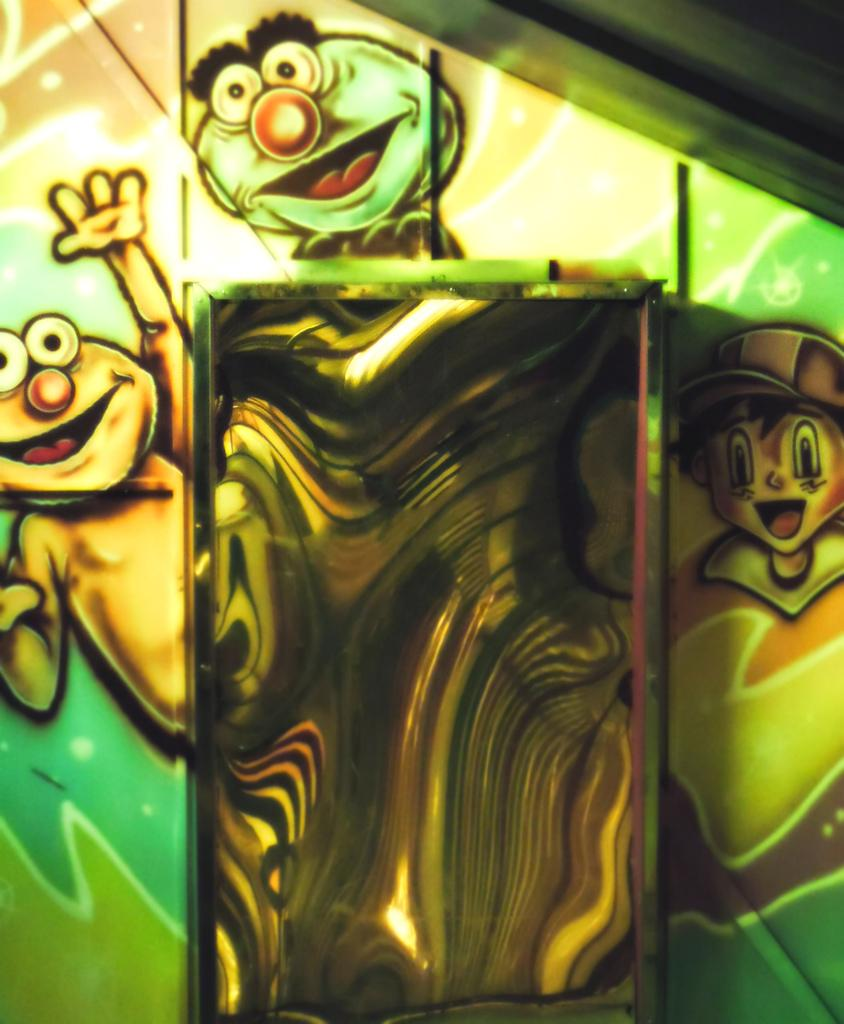What is depicted in the image? There is a painting of cartoon characters in the image. What can be inferred about the nature of the painting? The painting is likely colorful and playful, given that it features cartoon characters. On what surface is the painting placed? The painting is on a surface, but the specific type of surface is not mentioned in the facts. What type of crime is being committed by the cartoon characters in the image? There is no indication of any crime being committed in the image; it features a painting of cartoon characters. What hobbies do the cartoon characters in the image enjoy? The facts provided do not give any information about the hobbies of the cartoon characters in the image. 